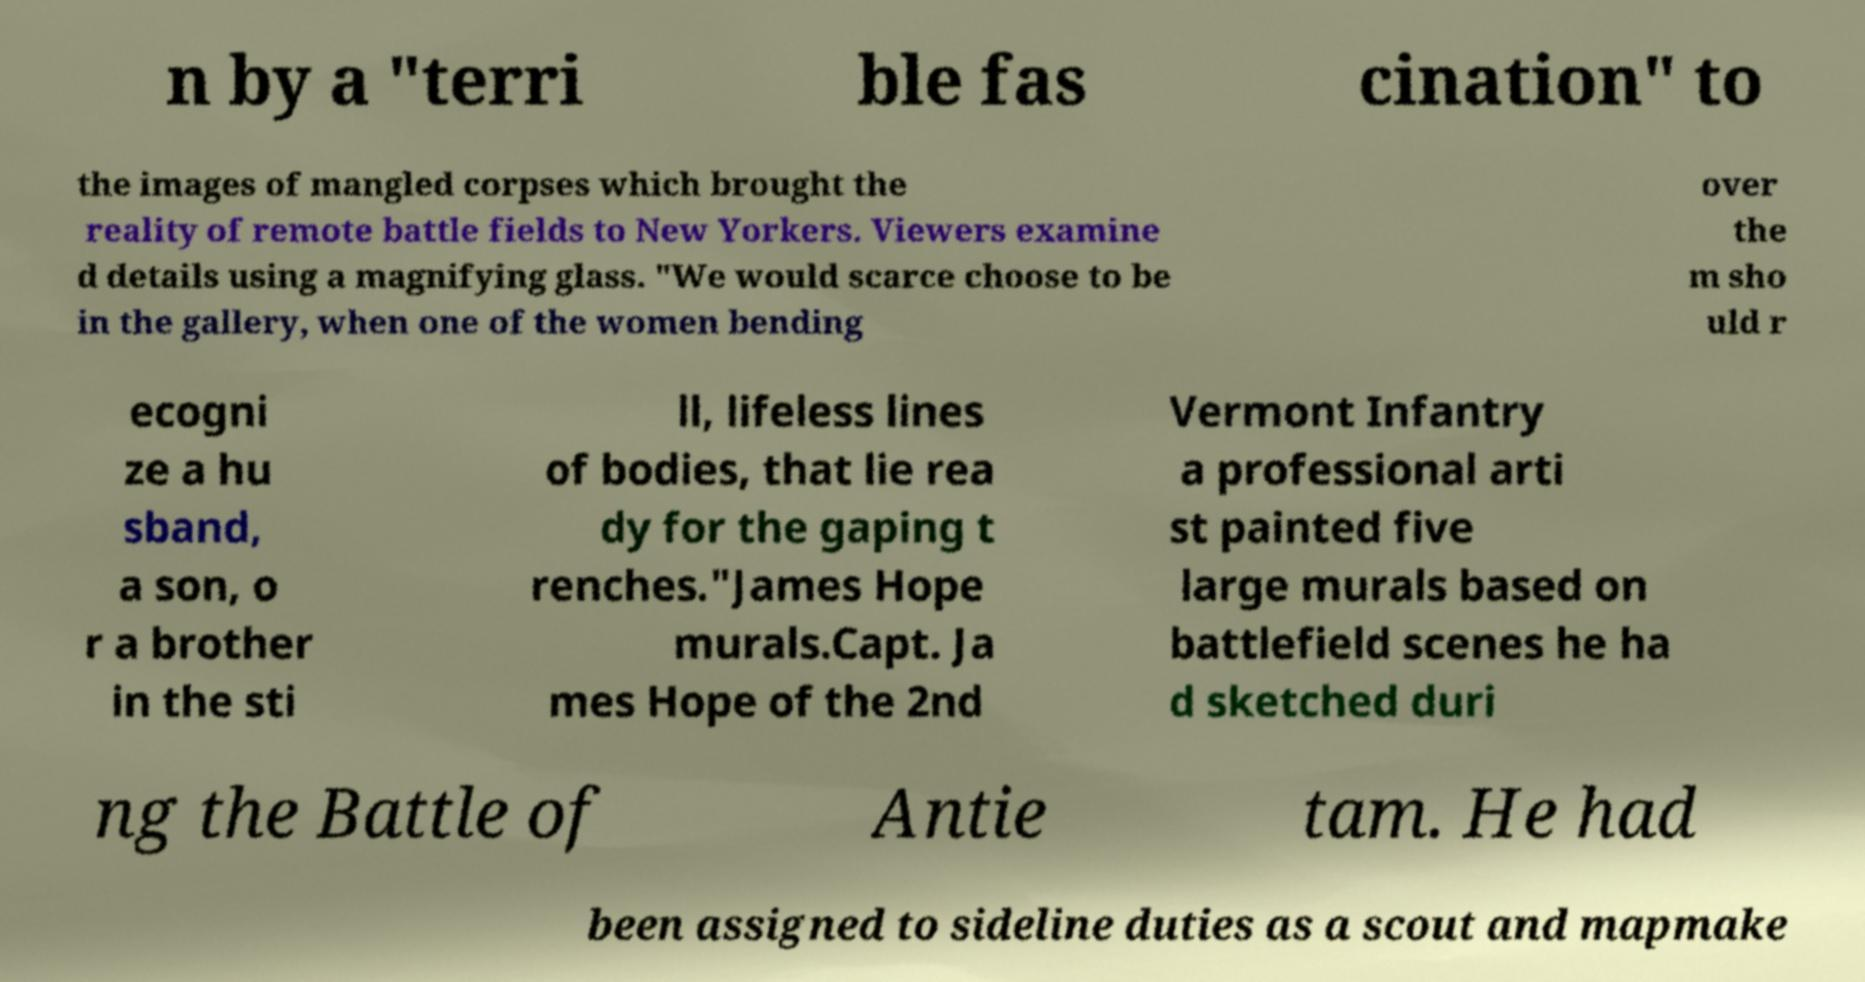Could you extract and type out the text from this image? n by a "terri ble fas cination" to the images of mangled corpses which brought the reality of remote battle fields to New Yorkers. Viewers examine d details using a magnifying glass. "We would scarce choose to be in the gallery, when one of the women bending over the m sho uld r ecogni ze a hu sband, a son, o r a brother in the sti ll, lifeless lines of bodies, that lie rea dy for the gaping t renches."James Hope murals.Capt. Ja mes Hope of the 2nd Vermont Infantry a professional arti st painted five large murals based on battlefield scenes he ha d sketched duri ng the Battle of Antie tam. He had been assigned to sideline duties as a scout and mapmake 